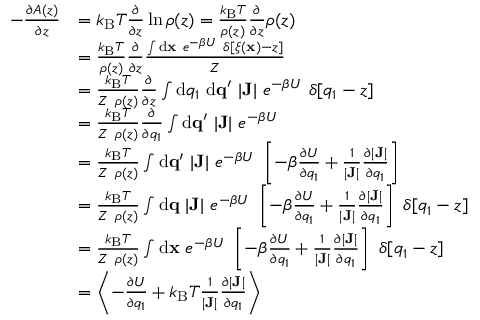Convert formula to latex. <formula><loc_0><loc_0><loc_500><loc_500>\begin{array} { r l } { - \frac { \partial A ( z ) } { \partial z } } & { = k _ { B } T \frac { \partial } { \partial z } \ln \rho ( z ) = \frac { k _ { B } T } { \rho ( z ) } \frac { \partial } { \partial z } \rho ( z ) } \\ & { = \frac { k _ { B } T } { \rho ( z ) } \frac { \partial } { \partial z } \frac { \int { d } { x } \ e ^ { - \beta U } \ \delta [ \xi ( { x } ) - z ] } { Z } } \\ & { = \frac { k _ { B } T } { Z \ \rho ( z ) } \frac { \partial } { \partial z } \int { d } q _ { 1 } \ { d } { q } ^ { \prime } \ | J | \ e ^ { - \beta U } \ \delta [ q _ { 1 } - z ] } \\ & { = \frac { k _ { B } T } { Z \ \rho ( z ) } \frac { \partial } { \partial q _ { 1 } } \int { d } { q } ^ { \prime } \ | J | \ e ^ { - \beta U } \ } \\ & { = \frac { k _ { B } T } { Z \ \rho ( z ) } \int { d } { q } ^ { \prime } \ | J | \ e ^ { - \beta U } \ \left [ - \beta \frac { \partial U } { \partial q _ { 1 } } + \frac { 1 } { | J | } \frac { \partial | J | } { \partial q _ { 1 } } \right ] } \\ & { = \frac { k _ { B } T } { Z \ \rho ( z ) } \int { d } { q } \ | J | \ e ^ { - \beta U } \ \left [ - \beta \frac { \partial U } { \partial q _ { 1 } } + \frac { 1 } { | J | } \frac { \partial | J | } { \partial q _ { 1 } } \right ] \ \delta [ q _ { 1 } - z ] } \\ & { = \frac { k _ { B } T } { Z \ \rho ( z ) } \int { d } { x } \ e ^ { - \beta U } \ \left [ - \beta \frac { \partial U } { \partial q _ { 1 } } + \frac { 1 } { | J | } \frac { \partial | J | } { \partial q _ { 1 } } \right ] \ \delta [ q _ { 1 } - z ] } \\ & { = \left < - \frac { \partial U } { \partial q _ { 1 } } + k _ { B } T \frac { 1 } { | J | } \frac { \partial | J | } { \partial q _ { 1 } } \right > } \end{array}</formula> 